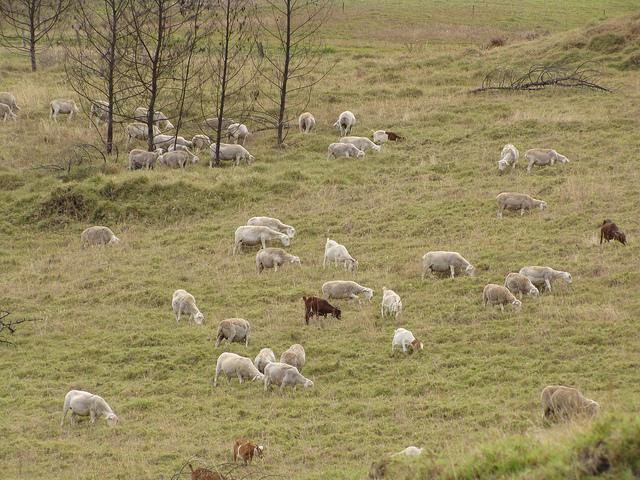How many giraffes are facing to the right?
Give a very brief answer. 0. 